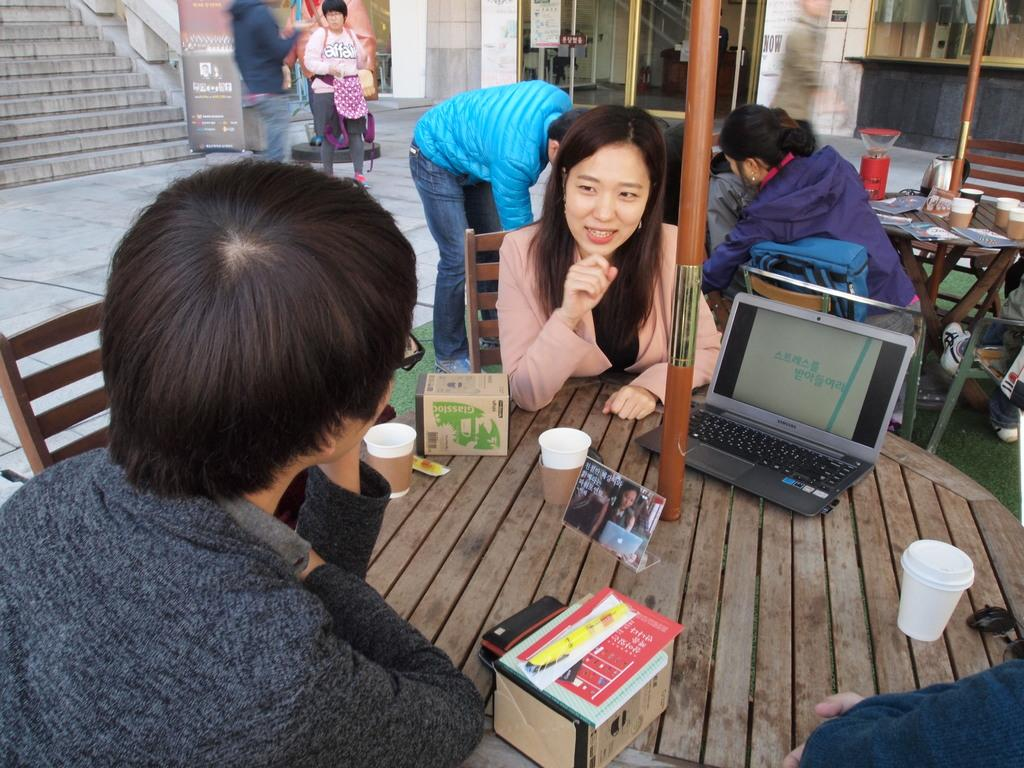What are the two people on the table doing? The two people are sitting on a table. What else can be seen on the table besides the people? Food items and a laptop are present on the table. How many people are sitting on tables in the background? There are many people sitting on tables in the background. How many guides are present in the image? There is no mention of a guide in the image, so it cannot be determined how many are present. 